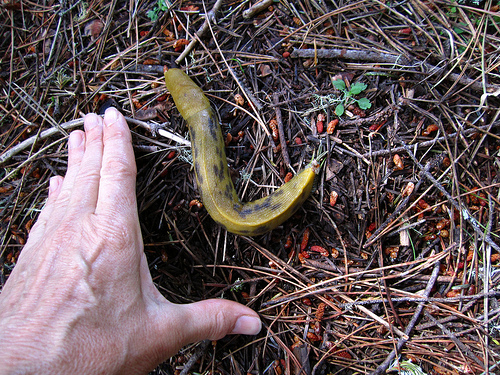<image>
Can you confirm if the snail is to the right of the man? Yes. From this viewpoint, the snail is positioned to the right side relative to the man. 